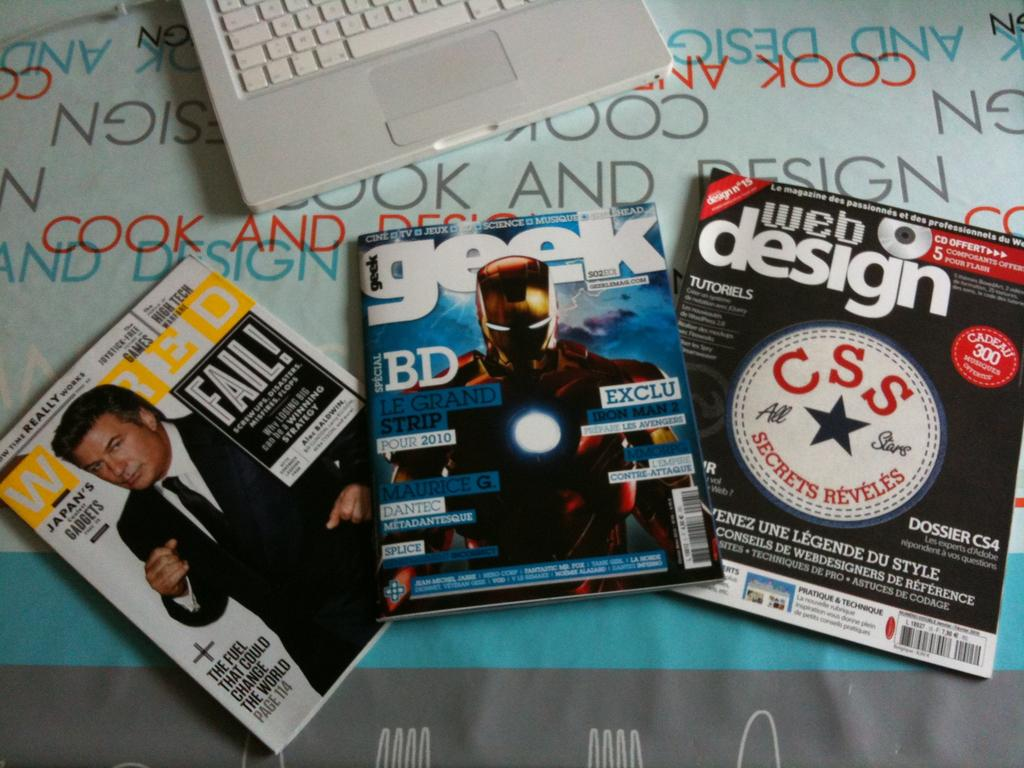<image>
Offer a succinct explanation of the picture presented. the magizinescovers of wired, geek and web design magizine 